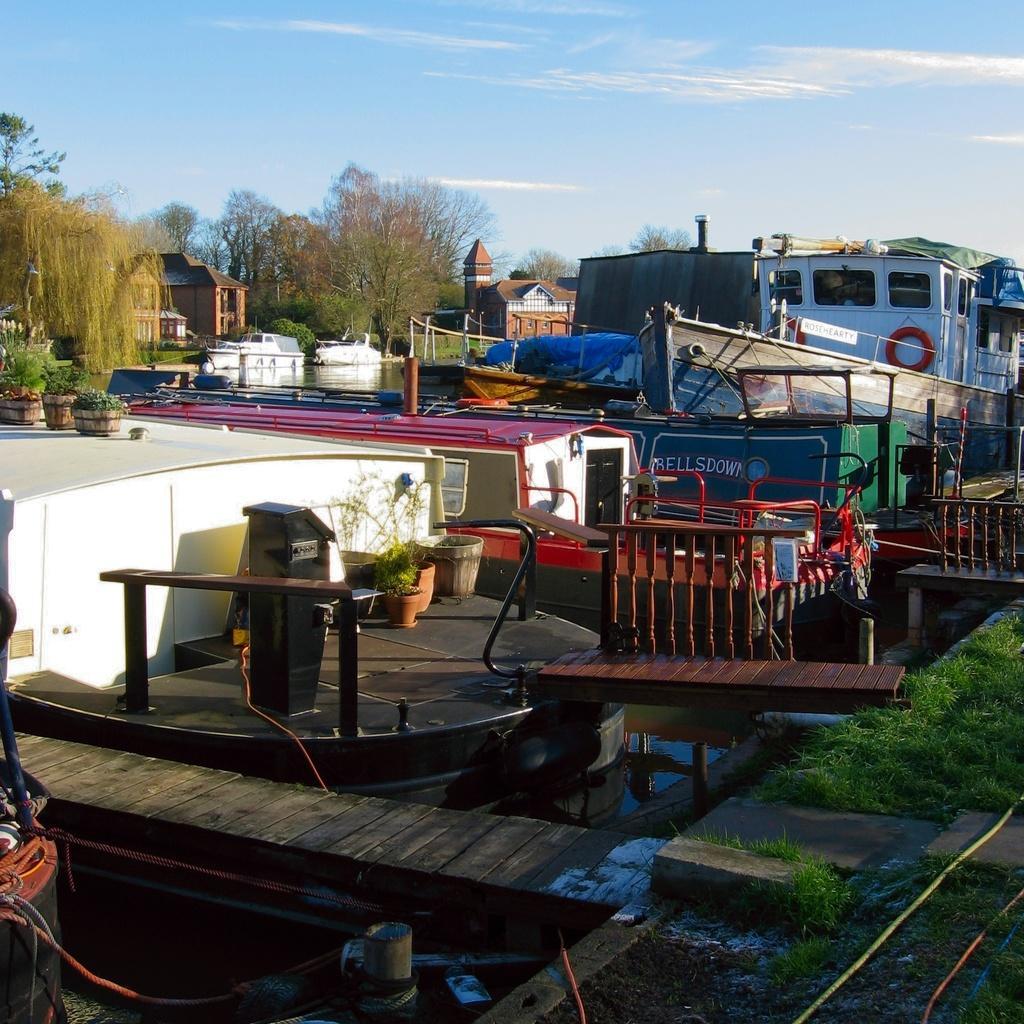Please provide a concise description of this image. In this picture I can see boats on the water, there are plants, trees, houses, grass, wooden pier and some other items, and in the background there is sky. 